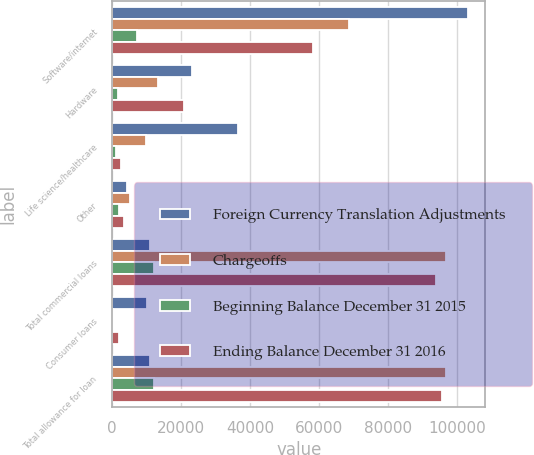<chart> <loc_0><loc_0><loc_500><loc_500><stacked_bar_chart><ecel><fcel>Software/internet<fcel>Hardware<fcel>Life science/healthcare<fcel>Other<fcel>Total commercial loans<fcel>Consumer loans<fcel>Total allowance for loan<nl><fcel>Foreign Currency Translation Adjustments<fcel>103045<fcel>23085<fcel>36576<fcel>4252<fcel>11061<fcel>10168<fcel>11061<nl><fcel>Chargeoffs<fcel>68784<fcel>13233<fcel>9693<fcel>5045<fcel>96755<fcel>102<fcel>96857<nl><fcel>Beginning Balance December 31 2015<fcel>7278<fcel>1667<fcel>1129<fcel>1880<fcel>11954<fcel>258<fcel>12212<nl><fcel>Ending Balance December 31 2016<fcel>58350<fcel>20851<fcel>2543<fcel>3373<fcel>93885<fcel>1812<fcel>95697<nl></chart> 